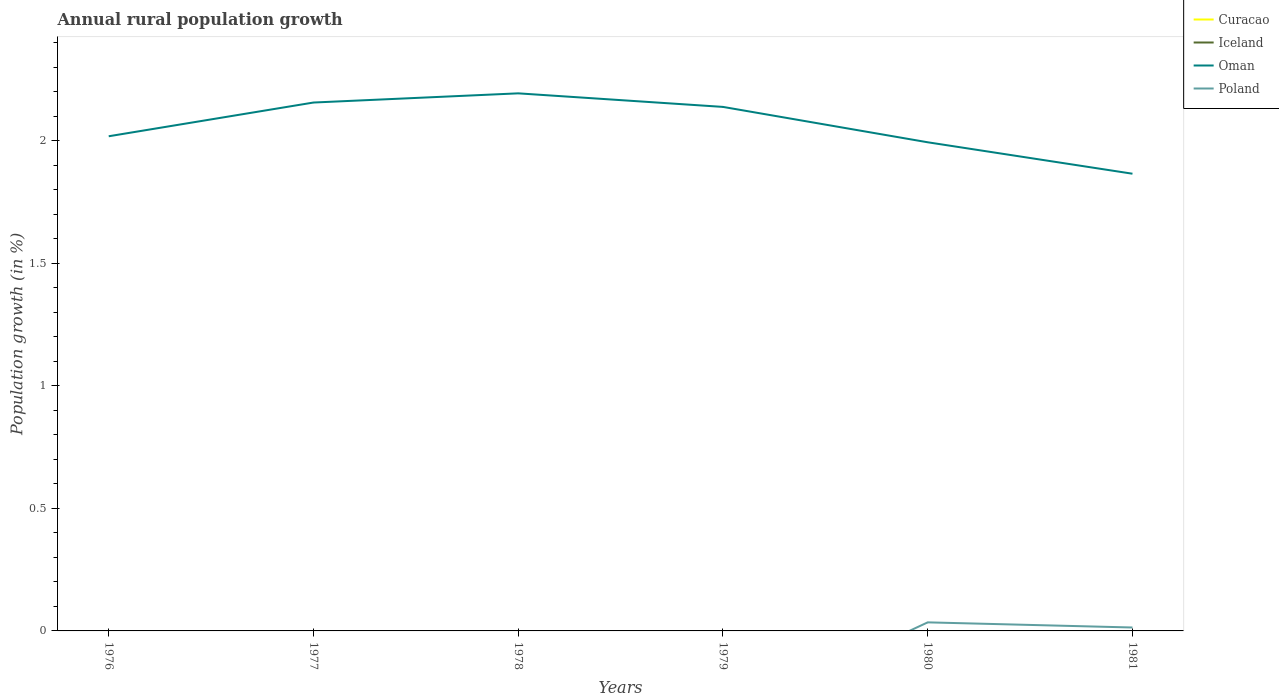Does the line corresponding to Oman intersect with the line corresponding to Curacao?
Provide a succinct answer. No. Is the number of lines equal to the number of legend labels?
Provide a succinct answer. No. Across all years, what is the maximum percentage of rural population growth in Oman?
Provide a succinct answer. 1.87. What is the total percentage of rural population growth in Oman in the graph?
Keep it short and to the point. 0.29. What is the difference between the highest and the second highest percentage of rural population growth in Oman?
Provide a short and direct response. 0.33. How many lines are there?
Your answer should be very brief. 2. How many years are there in the graph?
Keep it short and to the point. 6. What is the difference between two consecutive major ticks on the Y-axis?
Provide a short and direct response. 0.5. Are the values on the major ticks of Y-axis written in scientific E-notation?
Provide a short and direct response. No. Does the graph contain any zero values?
Offer a very short reply. Yes. Does the graph contain grids?
Give a very brief answer. No. What is the title of the graph?
Make the answer very short. Annual rural population growth. Does "Bolivia" appear as one of the legend labels in the graph?
Give a very brief answer. No. What is the label or title of the X-axis?
Offer a terse response. Years. What is the label or title of the Y-axis?
Provide a short and direct response. Population growth (in %). What is the Population growth (in %) of Curacao in 1976?
Offer a very short reply. 0. What is the Population growth (in %) in Oman in 1976?
Offer a terse response. 2.02. What is the Population growth (in %) in Poland in 1976?
Give a very brief answer. 0. What is the Population growth (in %) in Curacao in 1977?
Provide a succinct answer. 0. What is the Population growth (in %) of Oman in 1977?
Offer a very short reply. 2.16. What is the Population growth (in %) in Curacao in 1978?
Provide a succinct answer. 0. What is the Population growth (in %) in Oman in 1978?
Your response must be concise. 2.19. What is the Population growth (in %) in Curacao in 1979?
Offer a very short reply. 0. What is the Population growth (in %) of Iceland in 1979?
Keep it short and to the point. 0. What is the Population growth (in %) of Oman in 1979?
Your answer should be compact. 2.14. What is the Population growth (in %) in Poland in 1979?
Your answer should be compact. 0. What is the Population growth (in %) of Curacao in 1980?
Provide a short and direct response. 0. What is the Population growth (in %) of Oman in 1980?
Give a very brief answer. 1.99. What is the Population growth (in %) in Poland in 1980?
Offer a terse response. 0.03. What is the Population growth (in %) of Iceland in 1981?
Keep it short and to the point. 0. What is the Population growth (in %) of Oman in 1981?
Your answer should be compact. 1.87. What is the Population growth (in %) of Poland in 1981?
Your answer should be very brief. 0.01. Across all years, what is the maximum Population growth (in %) of Oman?
Ensure brevity in your answer.  2.19. Across all years, what is the maximum Population growth (in %) in Poland?
Make the answer very short. 0.03. Across all years, what is the minimum Population growth (in %) in Oman?
Provide a short and direct response. 1.87. Across all years, what is the minimum Population growth (in %) of Poland?
Your answer should be compact. 0. What is the total Population growth (in %) of Curacao in the graph?
Provide a short and direct response. 0. What is the total Population growth (in %) in Oman in the graph?
Provide a short and direct response. 12.37. What is the total Population growth (in %) of Poland in the graph?
Provide a succinct answer. 0.05. What is the difference between the Population growth (in %) of Oman in 1976 and that in 1977?
Make the answer very short. -0.14. What is the difference between the Population growth (in %) in Oman in 1976 and that in 1978?
Your response must be concise. -0.18. What is the difference between the Population growth (in %) in Oman in 1976 and that in 1979?
Ensure brevity in your answer.  -0.12. What is the difference between the Population growth (in %) in Oman in 1976 and that in 1980?
Provide a succinct answer. 0.02. What is the difference between the Population growth (in %) in Oman in 1976 and that in 1981?
Give a very brief answer. 0.15. What is the difference between the Population growth (in %) in Oman in 1977 and that in 1978?
Offer a very short reply. -0.04. What is the difference between the Population growth (in %) in Oman in 1977 and that in 1979?
Make the answer very short. 0.02. What is the difference between the Population growth (in %) of Oman in 1977 and that in 1980?
Provide a succinct answer. 0.16. What is the difference between the Population growth (in %) in Oman in 1977 and that in 1981?
Make the answer very short. 0.29. What is the difference between the Population growth (in %) of Oman in 1978 and that in 1979?
Offer a very short reply. 0.06. What is the difference between the Population growth (in %) of Oman in 1978 and that in 1980?
Your answer should be very brief. 0.2. What is the difference between the Population growth (in %) of Oman in 1978 and that in 1981?
Provide a short and direct response. 0.33. What is the difference between the Population growth (in %) in Oman in 1979 and that in 1980?
Keep it short and to the point. 0.14. What is the difference between the Population growth (in %) of Oman in 1979 and that in 1981?
Your response must be concise. 0.27. What is the difference between the Population growth (in %) of Oman in 1980 and that in 1981?
Your answer should be very brief. 0.13. What is the difference between the Population growth (in %) of Poland in 1980 and that in 1981?
Offer a terse response. 0.02. What is the difference between the Population growth (in %) of Oman in 1976 and the Population growth (in %) of Poland in 1980?
Provide a short and direct response. 1.98. What is the difference between the Population growth (in %) of Oman in 1976 and the Population growth (in %) of Poland in 1981?
Your answer should be very brief. 2. What is the difference between the Population growth (in %) of Oman in 1977 and the Population growth (in %) of Poland in 1980?
Your response must be concise. 2.12. What is the difference between the Population growth (in %) of Oman in 1977 and the Population growth (in %) of Poland in 1981?
Your answer should be very brief. 2.14. What is the difference between the Population growth (in %) in Oman in 1978 and the Population growth (in %) in Poland in 1980?
Your answer should be compact. 2.16. What is the difference between the Population growth (in %) in Oman in 1978 and the Population growth (in %) in Poland in 1981?
Offer a very short reply. 2.18. What is the difference between the Population growth (in %) in Oman in 1979 and the Population growth (in %) in Poland in 1980?
Give a very brief answer. 2.1. What is the difference between the Population growth (in %) in Oman in 1979 and the Population growth (in %) in Poland in 1981?
Keep it short and to the point. 2.12. What is the difference between the Population growth (in %) of Oman in 1980 and the Population growth (in %) of Poland in 1981?
Provide a short and direct response. 1.98. What is the average Population growth (in %) of Iceland per year?
Ensure brevity in your answer.  0. What is the average Population growth (in %) of Oman per year?
Ensure brevity in your answer.  2.06. What is the average Population growth (in %) in Poland per year?
Keep it short and to the point. 0.01. In the year 1980, what is the difference between the Population growth (in %) in Oman and Population growth (in %) in Poland?
Give a very brief answer. 1.96. In the year 1981, what is the difference between the Population growth (in %) in Oman and Population growth (in %) in Poland?
Make the answer very short. 1.85. What is the ratio of the Population growth (in %) in Oman in 1976 to that in 1977?
Make the answer very short. 0.94. What is the ratio of the Population growth (in %) in Oman in 1976 to that in 1978?
Provide a succinct answer. 0.92. What is the ratio of the Population growth (in %) in Oman in 1976 to that in 1979?
Ensure brevity in your answer.  0.94. What is the ratio of the Population growth (in %) of Oman in 1976 to that in 1980?
Offer a very short reply. 1.01. What is the ratio of the Population growth (in %) of Oman in 1976 to that in 1981?
Provide a short and direct response. 1.08. What is the ratio of the Population growth (in %) of Oman in 1977 to that in 1978?
Provide a succinct answer. 0.98. What is the ratio of the Population growth (in %) of Oman in 1977 to that in 1979?
Offer a terse response. 1.01. What is the ratio of the Population growth (in %) of Oman in 1977 to that in 1980?
Your answer should be very brief. 1.08. What is the ratio of the Population growth (in %) in Oman in 1977 to that in 1981?
Give a very brief answer. 1.16. What is the ratio of the Population growth (in %) of Oman in 1978 to that in 1979?
Provide a short and direct response. 1.03. What is the ratio of the Population growth (in %) of Oman in 1978 to that in 1980?
Your answer should be compact. 1.1. What is the ratio of the Population growth (in %) of Oman in 1978 to that in 1981?
Give a very brief answer. 1.18. What is the ratio of the Population growth (in %) in Oman in 1979 to that in 1980?
Your answer should be compact. 1.07. What is the ratio of the Population growth (in %) of Oman in 1979 to that in 1981?
Your answer should be very brief. 1.15. What is the ratio of the Population growth (in %) in Oman in 1980 to that in 1981?
Provide a succinct answer. 1.07. What is the ratio of the Population growth (in %) of Poland in 1980 to that in 1981?
Your response must be concise. 2.5. What is the difference between the highest and the second highest Population growth (in %) in Oman?
Your answer should be very brief. 0.04. What is the difference between the highest and the lowest Population growth (in %) of Oman?
Keep it short and to the point. 0.33. What is the difference between the highest and the lowest Population growth (in %) of Poland?
Provide a succinct answer. 0.03. 